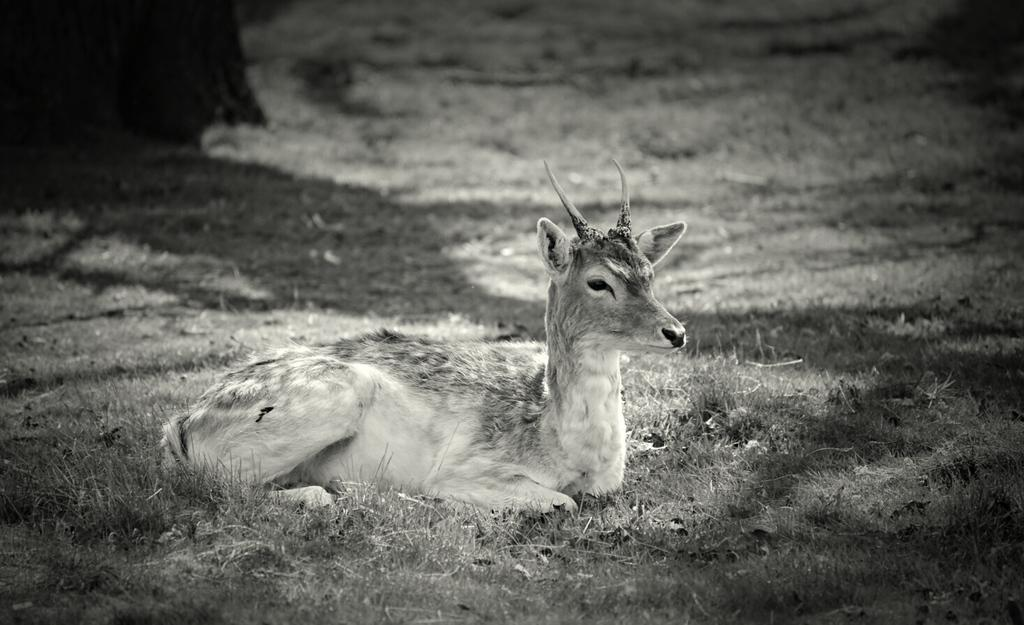What is the color scheme of the image? The image is black and white. What animal can be seen in the image? There is a deer in the image. Where is the deer located in the image? The deer is sitting on the grass. What is the caption for the image? There is no caption present in the image, as it is a photograph and not a text-based medium. How much does the deer cost in the image? The image is not a product or advertisement, so there is no price associated with the deer. 